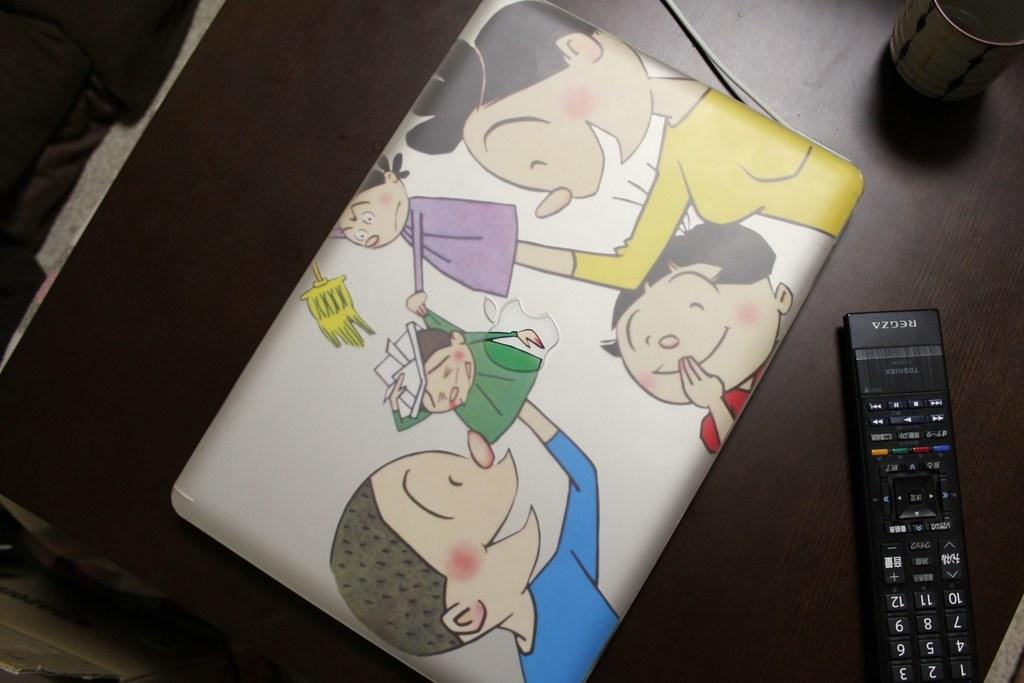<image>
Offer a succinct explanation of the picture presented. A colorful case with children playing next to a regza remote 